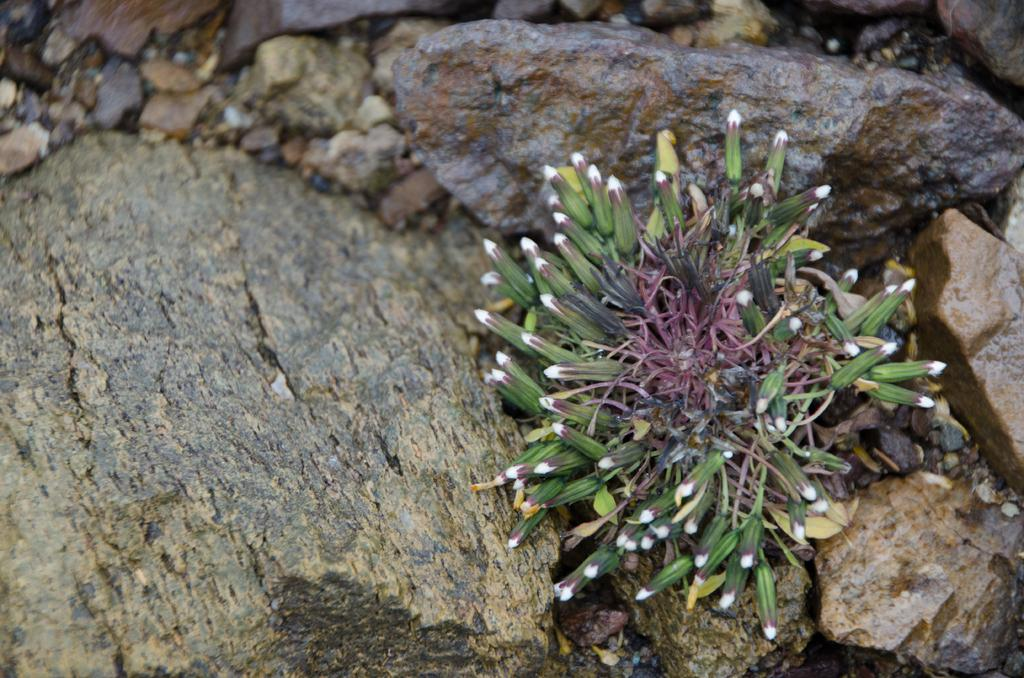What type of objects can be seen in the image? There are stones in the image. What is located in the front of the image? There is a plant in the front of the image. What type of shirt is the plant wearing in the image? There is no shirt present in the image, as the subject is a plant. 